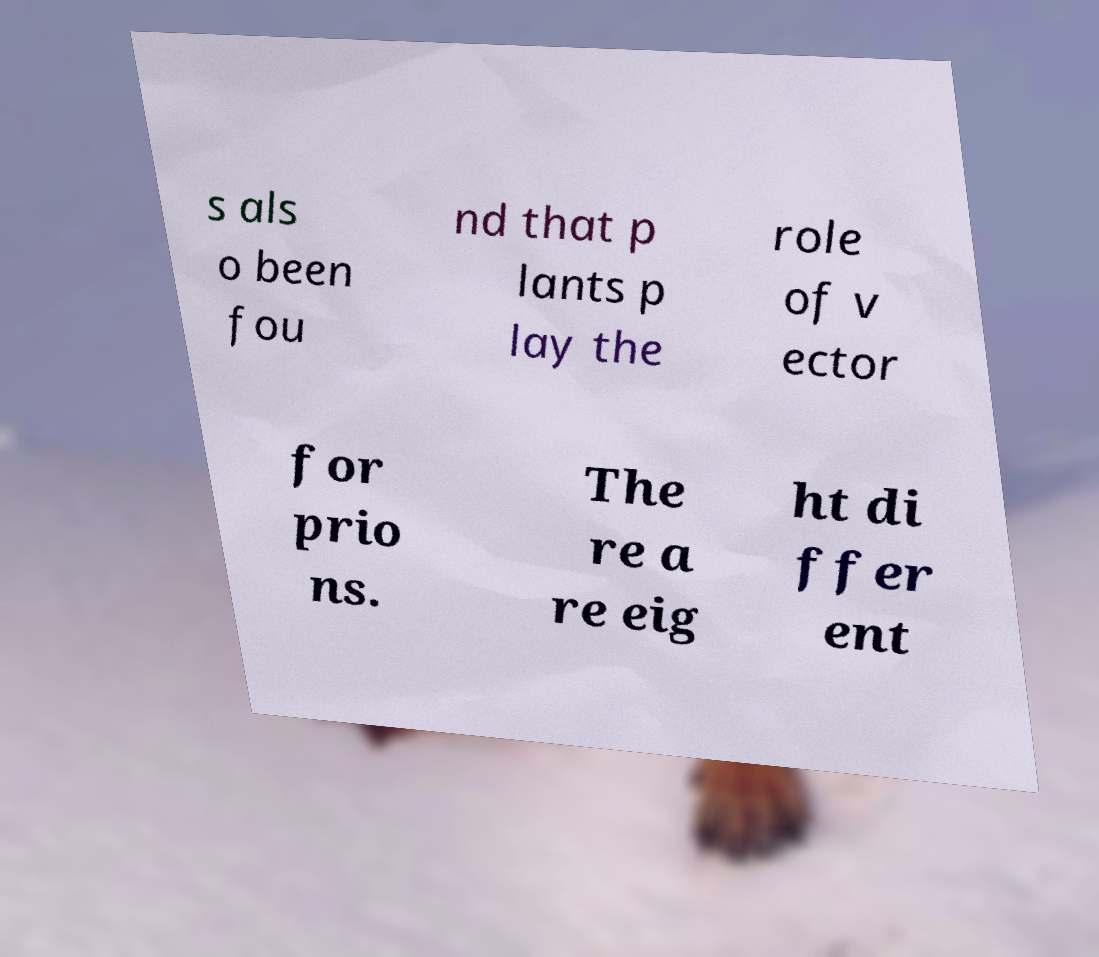For documentation purposes, I need the text within this image transcribed. Could you provide that? s als o been fou nd that p lants p lay the role of v ector for prio ns. The re a re eig ht di ffer ent 